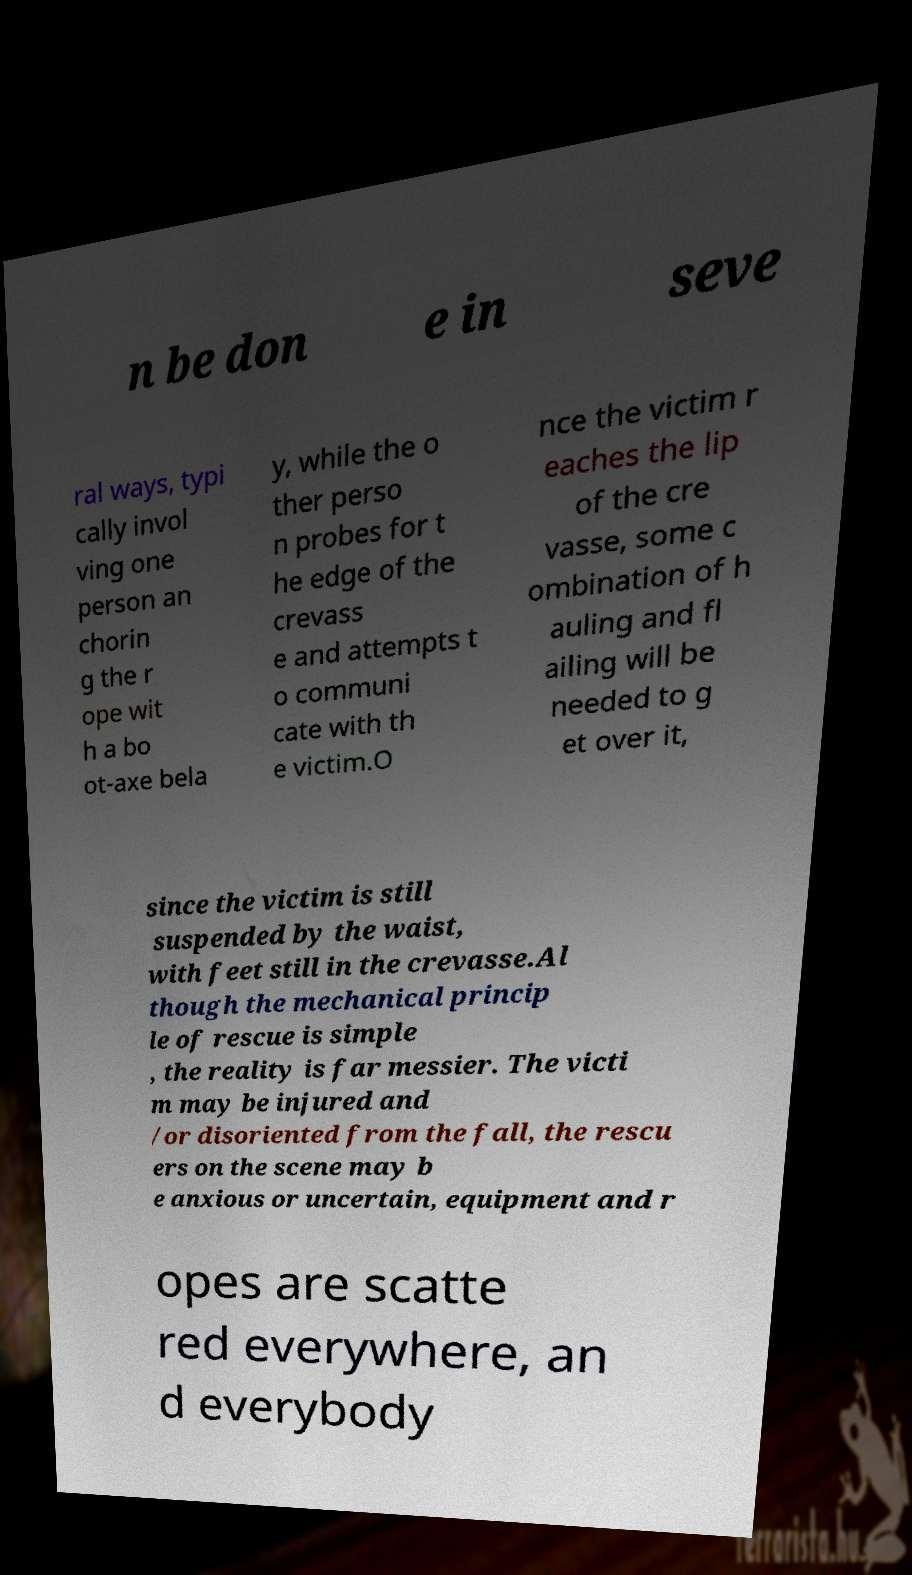I need the written content from this picture converted into text. Can you do that? n be don e in seve ral ways, typi cally invol ving one person an chorin g the r ope wit h a bo ot-axe bela y, while the o ther perso n probes for t he edge of the crevass e and attempts t o communi cate with th e victim.O nce the victim r eaches the lip of the cre vasse, some c ombination of h auling and fl ailing will be needed to g et over it, since the victim is still suspended by the waist, with feet still in the crevasse.Al though the mechanical princip le of rescue is simple , the reality is far messier. The victi m may be injured and /or disoriented from the fall, the rescu ers on the scene may b e anxious or uncertain, equipment and r opes are scatte red everywhere, an d everybody 